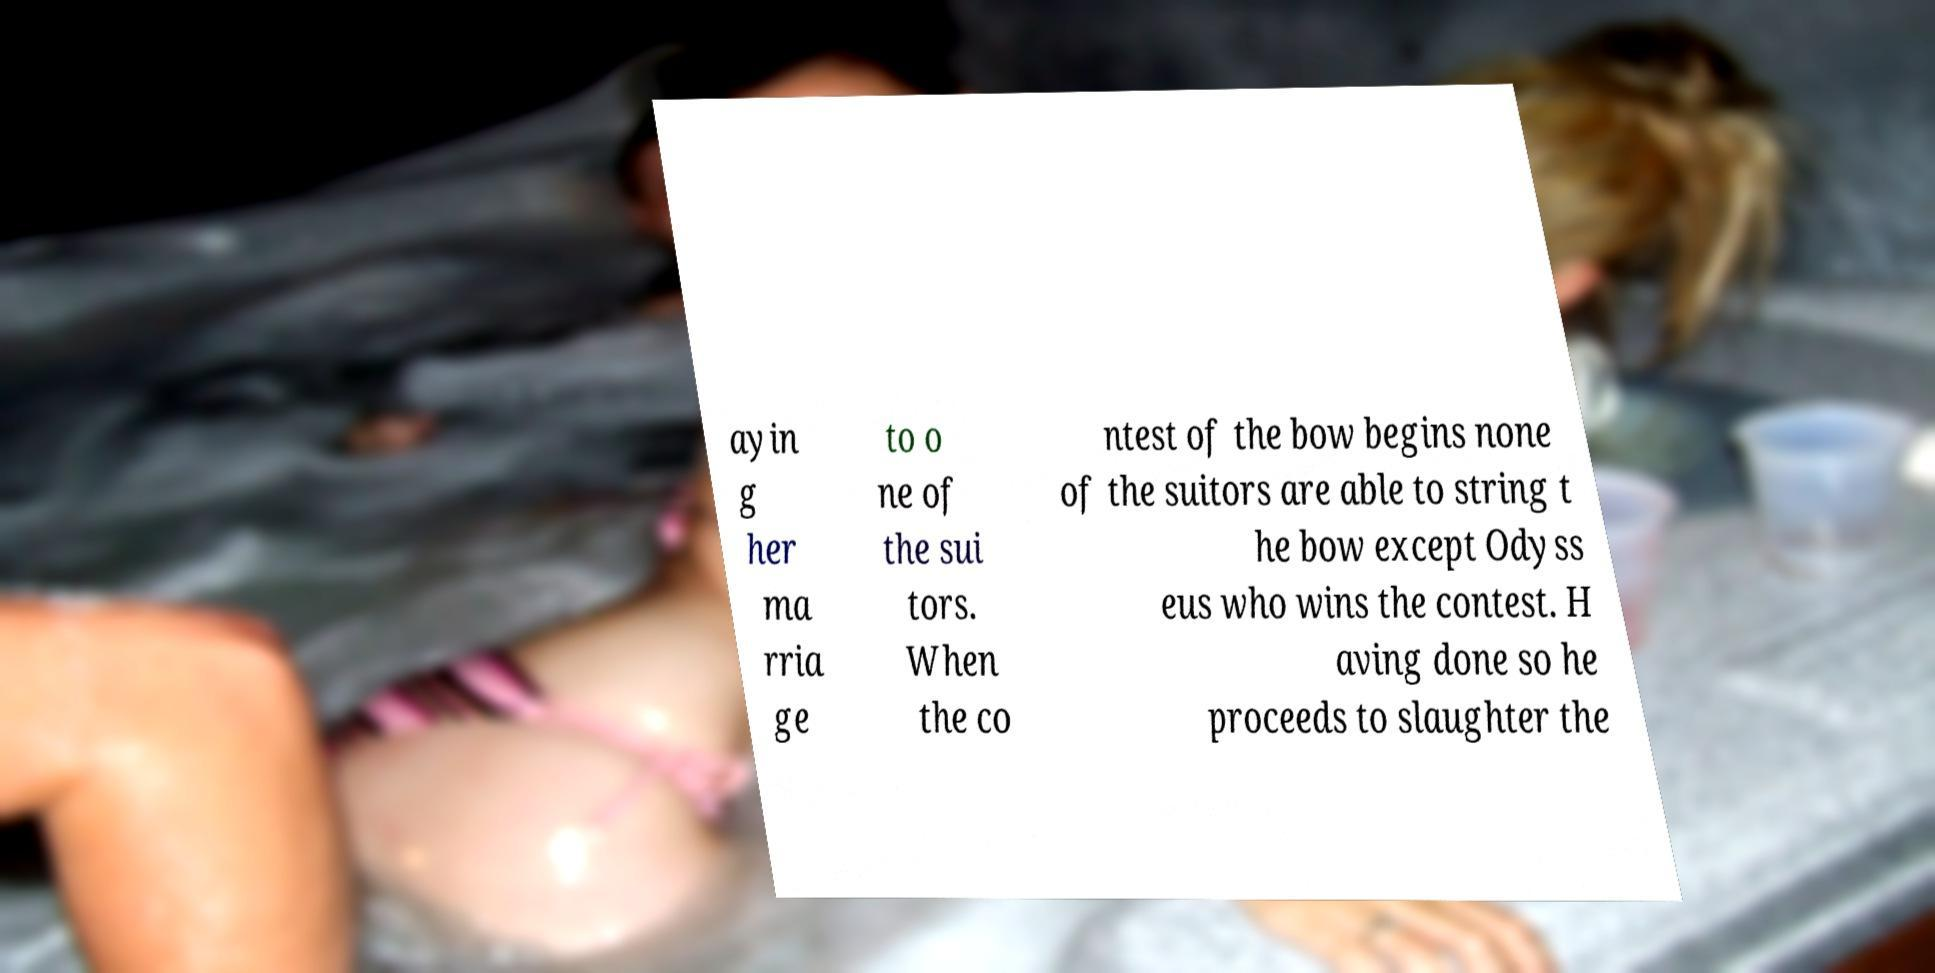Please read and relay the text visible in this image. What does it say? ayin g her ma rria ge to o ne of the sui tors. When the co ntest of the bow begins none of the suitors are able to string t he bow except Odyss eus who wins the contest. H aving done so he proceeds to slaughter the 